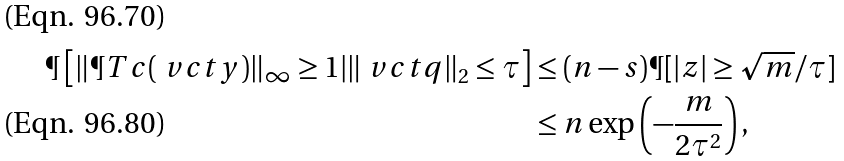Convert formula to latex. <formula><loc_0><loc_0><loc_500><loc_500>\P \left [ \| \P T c ( \ v c t { y } ) \| _ { \infty } \geq 1 | \| \ v c t { q } \| _ { 2 } \leq \tau \right ] & \leq ( n - s ) \P [ | z | \geq \sqrt { m } / \tau ] \\ & \leq n \exp \left ( - \frac { m } { 2 \tau ^ { 2 } } \right ) ,</formula> 